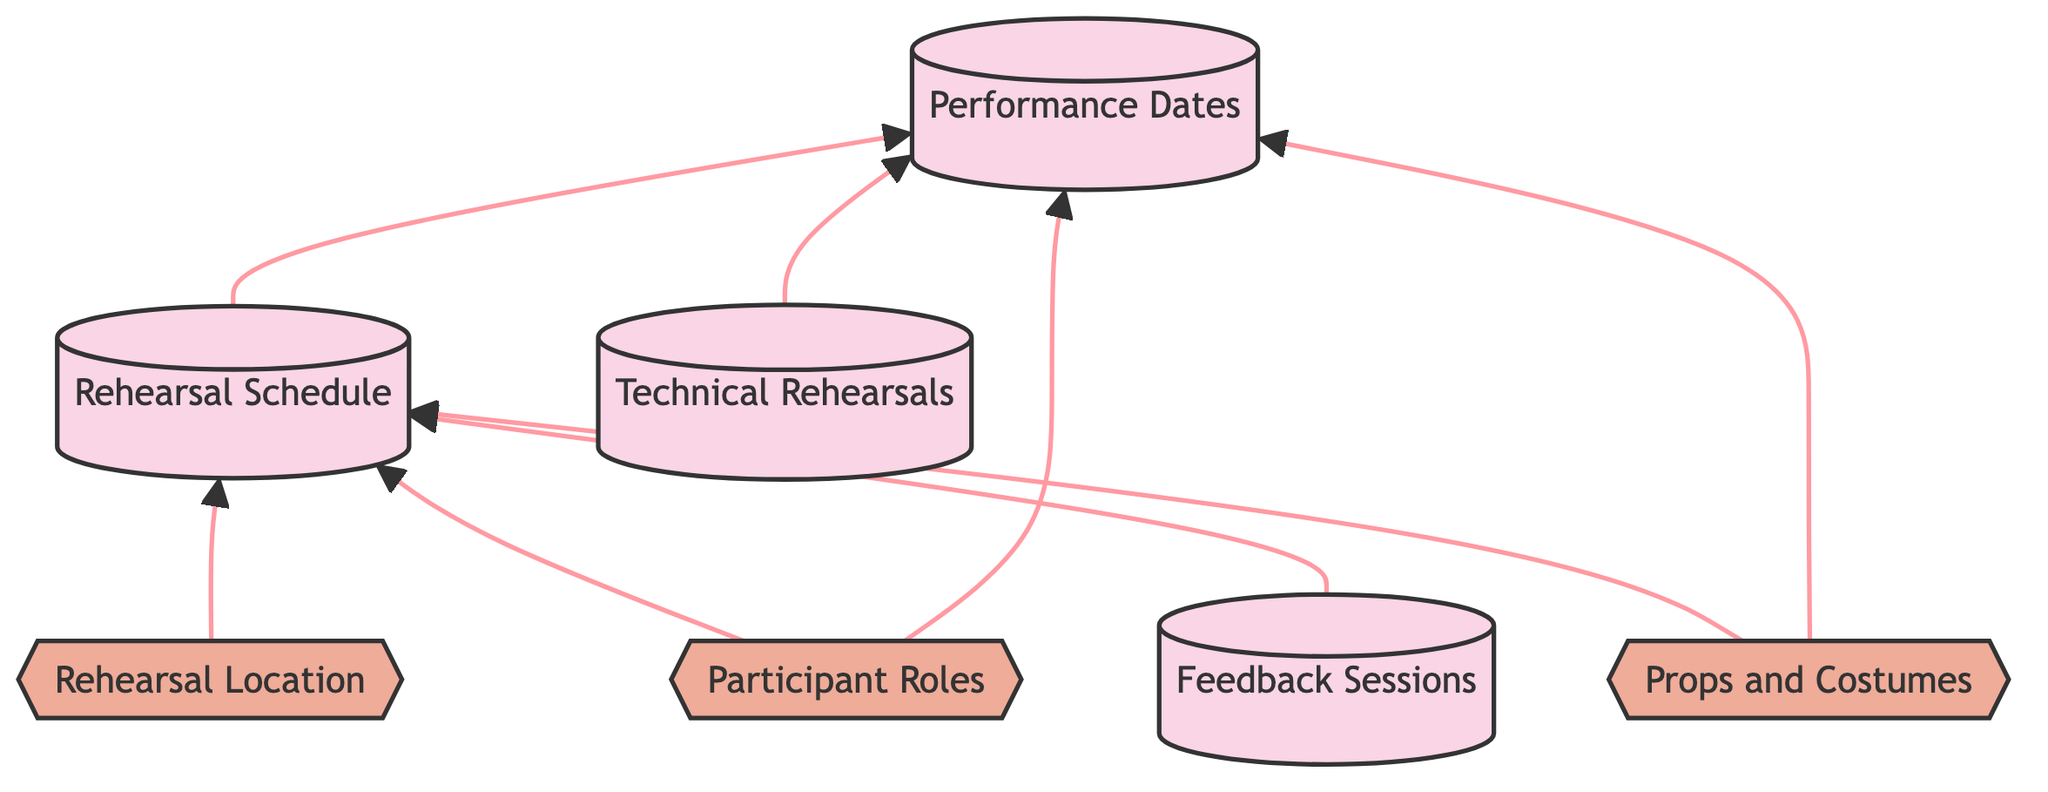What is the main focus of the diagram? The diagram primarily illustrates the schedule planning for rehearsals and performances, highlighting various elements such as schedules, roles, and resources necessary for the production.
Answer: Schedule planning for rehearsals and performances How many planning nodes are there in the diagram? Counting the nodes categorized as planning, we identify 4: Rehearsal Schedule, Performance Dates, Technical Rehearsals, and Feedback Sessions.
Answer: 4 What type of resource is 'Rehearsal Location'? 'Rehearsal Location' is categorized as a resource in the diagram, indicating it provides necessary space for rehearsals.
Answer: Resource Which role is indirectly linked to the Performance Dates? 'Participant Roles' is indirectly linked to Performance Dates through the relationship with the Rehearsal Schedule, indicating that participant roles impact both rehearsal and performance.
Answer: Participant Roles What is the relationship between 'Technical Rehearsals' and 'Performance Dates'? 'Technical Rehearsals' and 'Performance Dates' are connected in the planning flow, showing that technical rehearsals occur in preparation for the performances.
Answer: Planning connection How many total elements are present in the diagram? Adding both planning and resource elements, there are 7 total elements: 4 planning nodes and 3 resource nodes.
Answer: 7 Which element supports feedback for performers? 'Feedback Sessions' is the element designated for providing actors with feedback on their performances.
Answer: Feedback Sessions What kind of resources are included in the diagram? The diagram includes resources such as Participant Roles, Rehearsal Location, and Props and Costumes for the production.
Answer: Participant Roles, Rehearsal Location, Props and Costumes Which planning node links to both rehearsal and performance resources? 'Rehearsal Schedule' links to both the resource of Props and Costumes and the resource of Rehearsal Location, showing direct connections for both contexts.
Answer: Rehearsal Schedule 